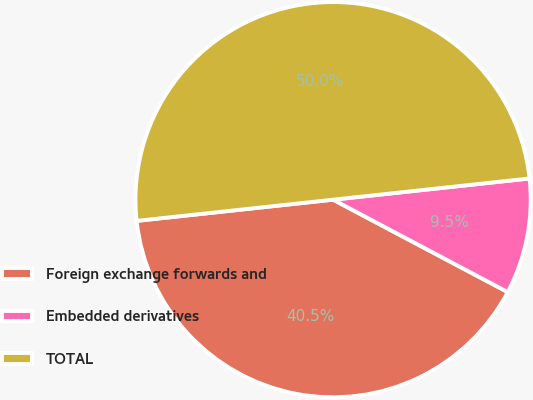Convert chart to OTSL. <chart><loc_0><loc_0><loc_500><loc_500><pie_chart><fcel>Foreign exchange forwards and<fcel>Embedded derivatives<fcel>TOTAL<nl><fcel>40.54%<fcel>9.46%<fcel>50.0%<nl></chart> 